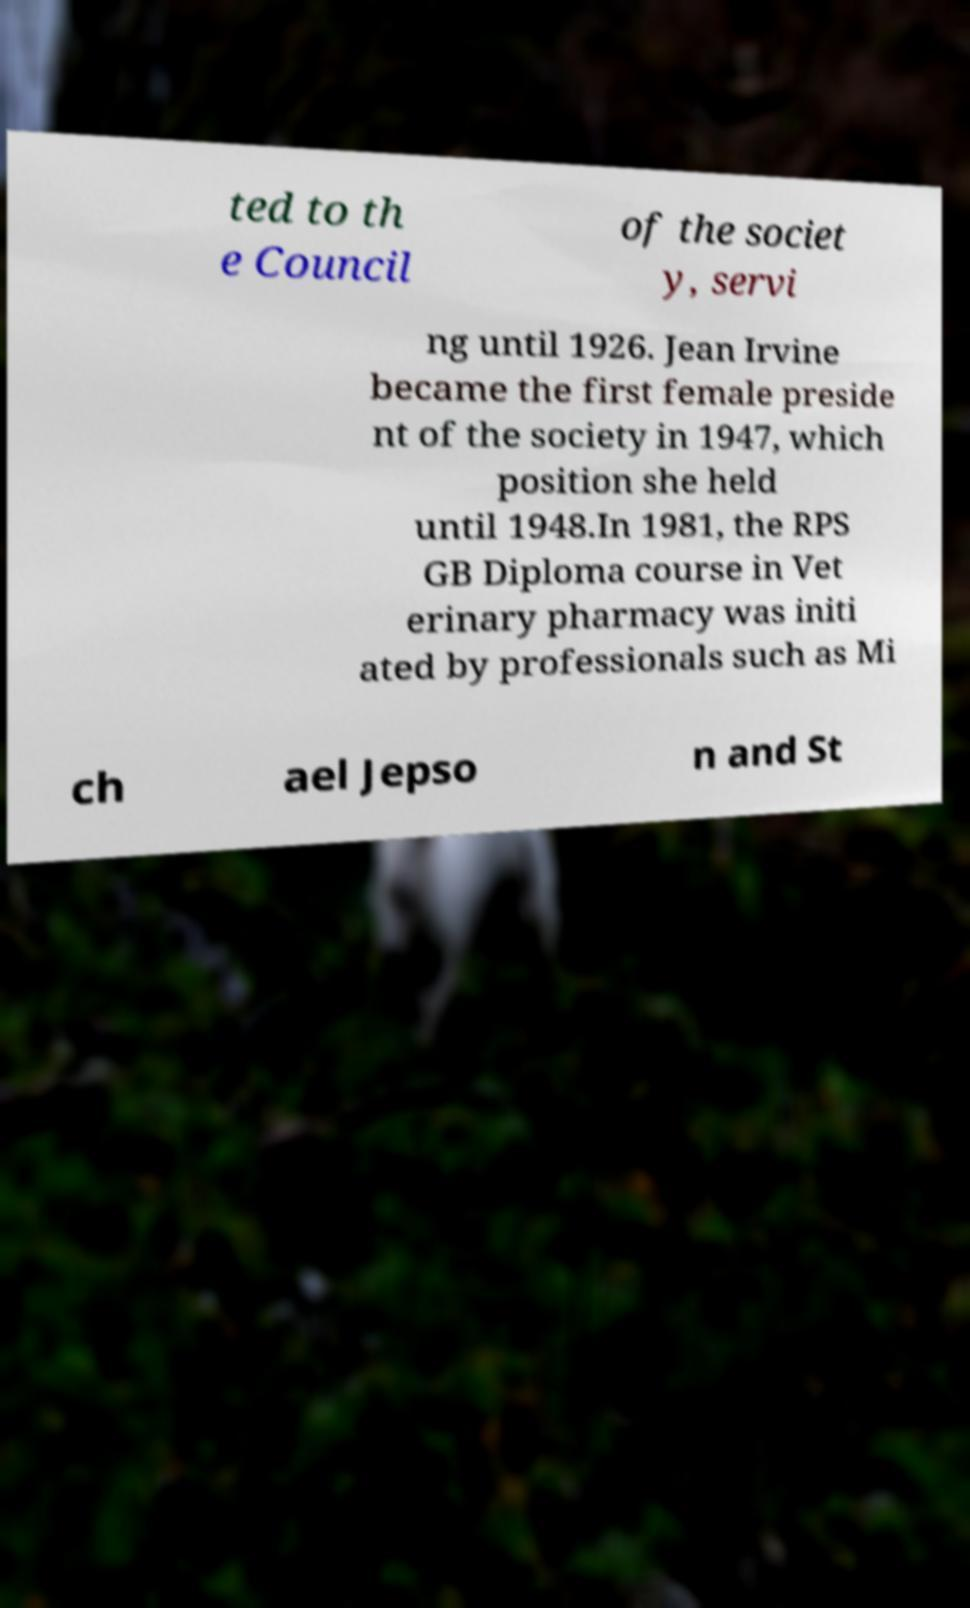What messages or text are displayed in this image? I need them in a readable, typed format. ted to th e Council of the societ y, servi ng until 1926. Jean Irvine became the first female preside nt of the society in 1947, which position she held until 1948.In 1981, the RPS GB Diploma course in Vet erinary pharmacy was initi ated by professionals such as Mi ch ael Jepso n and St 